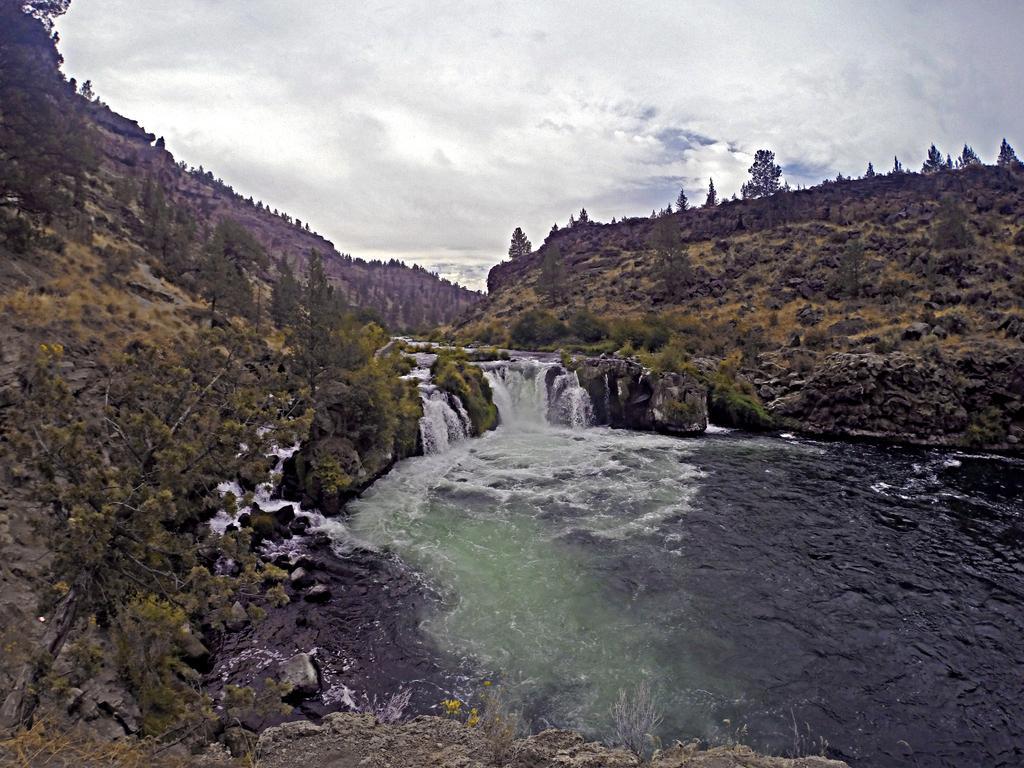Please provide a concise description of this image. On the left side, we see the trees. At the bottom, we see the water flow. There are trees and hills in the background. At the top, we see the sky. 